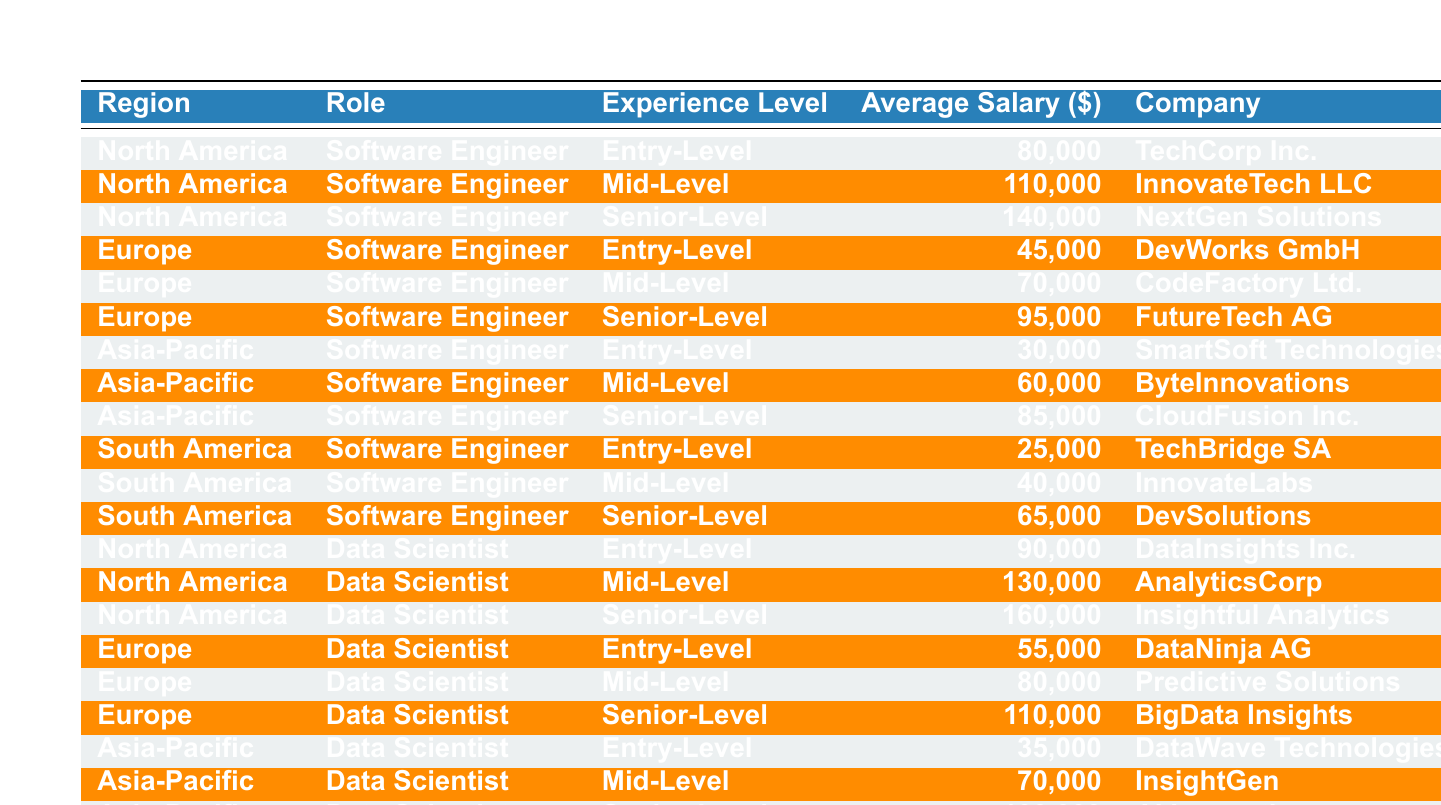What is the average salary for a Senior-Level Software Engineer in North America? The table shows that the average salary for a Senior-Level Software Engineer in North America is 140,000.
Answer: 140,000 Which region has the lowest average salary for Entry-Level Software Engineers? According to the table, South America has the lowest average salary for Entry-Level Software Engineers at 25,000.
Answer: South America What is the highest average salary for a Mid-Level Data Scientist across all regions? The highest average salary for a Mid-Level Data Scientist is 130,000 in North America, as seen in the table.
Answer: 130,000 Is the average salary for a Senior-Level Data Scientist in Europe higher than that in Asia-Pacific? The average salary for a Senior-Level Data Scientist in Europe is 110,000, while in Asia-Pacific it is 100,000, making the statement true.
Answer: Yes What is the average salary for all Entry-Level roles combined? The average salary for Entry-Level roles is calculated as (80,000 + 45,000 + 30,000 + 25,000 + 90,000 + 55,000 + 35,000) / 7 = 53,571.43, rounding gives approximately 53,571.
Answer: 53,571 Which company offers the highest salary for a Senior-Level Software Engineer? According to the table, NextGen Solutions offers the highest salary at 140,000 for a Senior-Level Software Engineer in North America.
Answer: NextGen Solutions What is the difference between the average salary of Mid-Level Data Scientists in North America and Europe? The average salary for Mid-Level Data Scientists in North America is 130,000, while in Europe it is 80,000. The difference is 130,000 - 80,000 = 50,000.
Answer: 50,000 Which experience level has the highest average salary in South America for Software Engineers? The table indicates that Senior-Level Software Engineers in South America have the highest average salary of 65,000.
Answer: Senior-Level Are the average salaries for Mid-Level Software Engineers in North America and Europe equal? The average salary for Mid-Level Software Engineers in North America is 110,000 and in Europe it is 70,000. Since they are not equal, the statement is false.
Answer: No What is the average salary for a Senior-Level role across all regions? The average salary for Senior-Level roles is (140,000 + 95,000 + 85,000 + 65,000 + 160,000 + 110,000 + 100,000) / 7 = 102,857.14, rounding gives approximately 102,857.
Answer: 102,857 